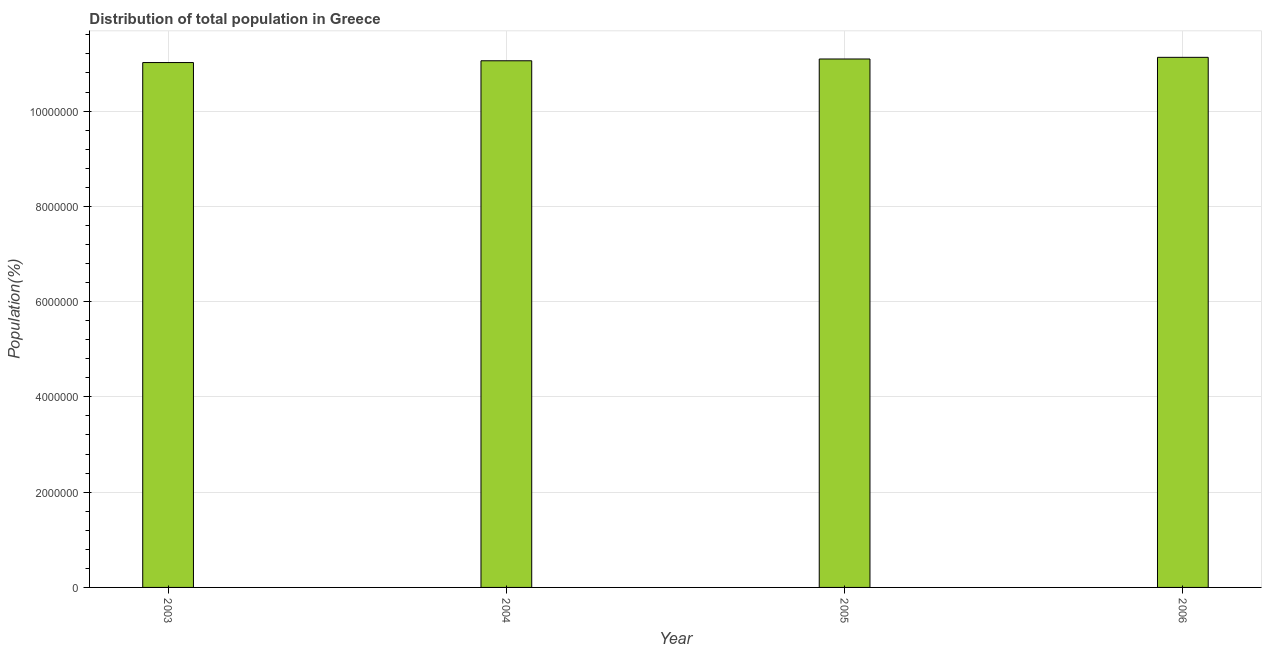Does the graph contain grids?
Provide a short and direct response. Yes. What is the title of the graph?
Offer a very short reply. Distribution of total population in Greece . What is the label or title of the X-axis?
Offer a very short reply. Year. What is the label or title of the Y-axis?
Provide a succinct answer. Population(%). What is the population in 2005?
Your response must be concise. 1.11e+07. Across all years, what is the maximum population?
Your answer should be very brief. 1.11e+07. Across all years, what is the minimum population?
Ensure brevity in your answer.  1.10e+07. In which year was the population maximum?
Your answer should be compact. 2006. In which year was the population minimum?
Offer a very short reply. 2003. What is the sum of the population?
Your answer should be very brief. 4.43e+07. What is the difference between the population in 2004 and 2006?
Keep it short and to the point. -7.22e+04. What is the average population per year?
Your response must be concise. 1.11e+07. What is the median population?
Your response must be concise. 1.11e+07. In how many years, is the population greater than 1200000 %?
Ensure brevity in your answer.  4. Do a majority of the years between 2003 and 2006 (inclusive) have population greater than 10000000 %?
Provide a succinct answer. Yes. Is the difference between the population in 2003 and 2004 greater than the difference between any two years?
Provide a short and direct response. No. What is the difference between the highest and the second highest population?
Ensure brevity in your answer.  3.50e+04. What is the difference between the highest and the lowest population?
Make the answer very short. 1.10e+05. In how many years, is the population greater than the average population taken over all years?
Ensure brevity in your answer.  2. How many years are there in the graph?
Your answer should be very brief. 4. Are the values on the major ticks of Y-axis written in scientific E-notation?
Provide a succinct answer. No. What is the Population(%) in 2003?
Ensure brevity in your answer.  1.10e+07. What is the Population(%) of 2004?
Offer a very short reply. 1.11e+07. What is the Population(%) in 2005?
Your answer should be very brief. 1.11e+07. What is the Population(%) of 2006?
Provide a succinct answer. 1.11e+07. What is the difference between the Population(%) in 2003 and 2004?
Your response must be concise. -3.74e+04. What is the difference between the Population(%) in 2003 and 2005?
Offer a very short reply. -7.46e+04. What is the difference between the Population(%) in 2003 and 2006?
Offer a terse response. -1.10e+05. What is the difference between the Population(%) in 2004 and 2005?
Give a very brief answer. -3.72e+04. What is the difference between the Population(%) in 2004 and 2006?
Offer a very short reply. -7.22e+04. What is the difference between the Population(%) in 2005 and 2006?
Provide a short and direct response. -3.50e+04. What is the ratio of the Population(%) in 2003 to that in 2004?
Keep it short and to the point. 1. What is the ratio of the Population(%) in 2003 to that in 2006?
Provide a succinct answer. 0.99. What is the ratio of the Population(%) in 2005 to that in 2006?
Keep it short and to the point. 1. 